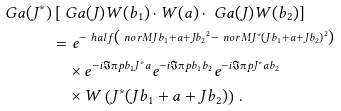Convert formula to latex. <formula><loc_0><loc_0><loc_500><loc_500>\ G a ( J ^ { * } ) & \left [ \ G a ( J ) W ( b _ { 1 } ) \cdot W ( a ) \cdot \ G a ( J ) W ( b _ { 2 } ) \right ] \\ & = e ^ { - \ h a l f \left ( \ n o r M { J b _ { 1 } + a + J b _ { 2 } } ^ { 2 } - \ n o r M { J ^ { * } ( J b _ { 1 } + a + J b _ { 2 } ) } ^ { 2 } \right ) } \\ & \quad \times e ^ { - i \Im \i p { b _ { 1 } } { J ^ { * } a } } e ^ { - i \Im \i p { b _ { 1 } } { b _ { 2 } } } e ^ { - i \Im \i p { J ^ { * } a } { b _ { 2 } } } \\ & \quad \times W \left ( J ^ { * } ( J b _ { 1 } + a + J b _ { 2 } ) \right ) \, .</formula> 